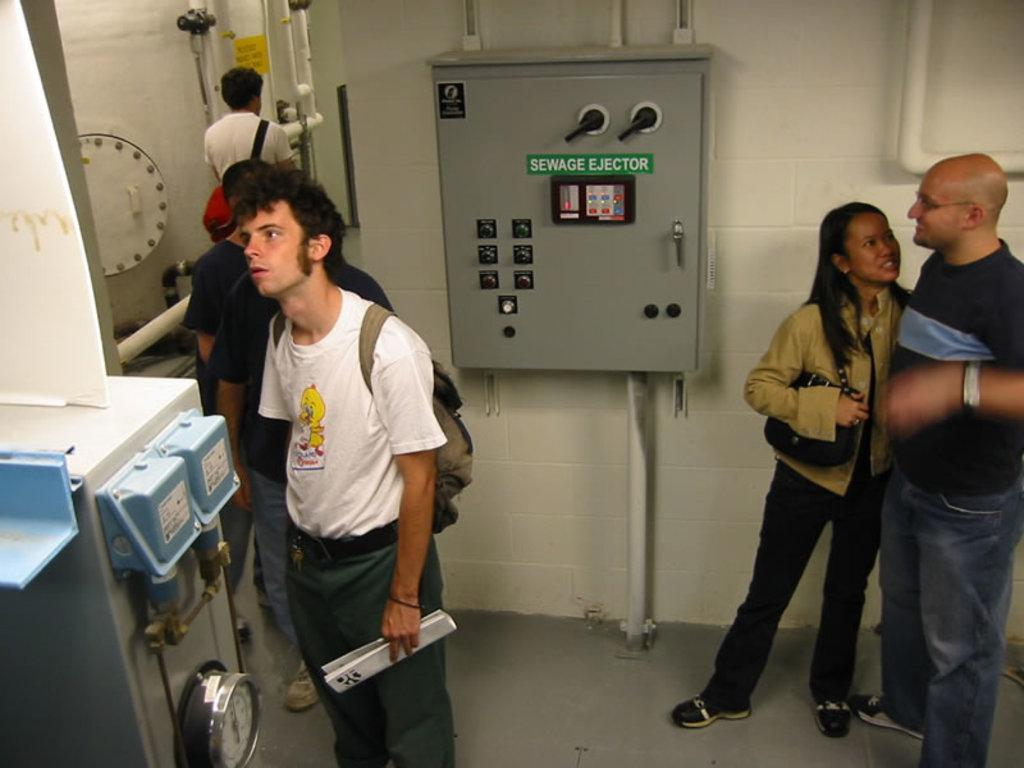How many persons are visible in the image? There are persons standing in the image. What is the surface on which the persons are standing? The persons are standing on the ground and on a wall. What type of objects can be seen in the image besides the persons? There are pipes and machines in the image. What are some of the persons wearing? Some of the persons are wearing bags. What type of range can be seen in the image? There is no range present in the image. What is the governor doing in the image? There is no governor present in the image. 